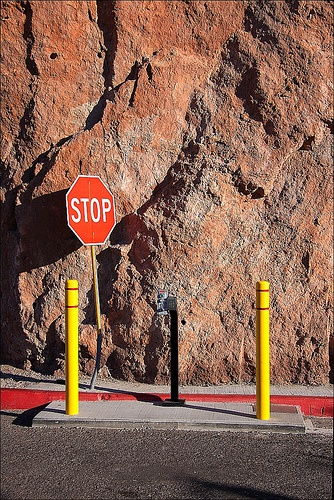Describe the objects in this image and their specific colors. I can see a stop sign in black, red, white, and salmon tones in this image. 